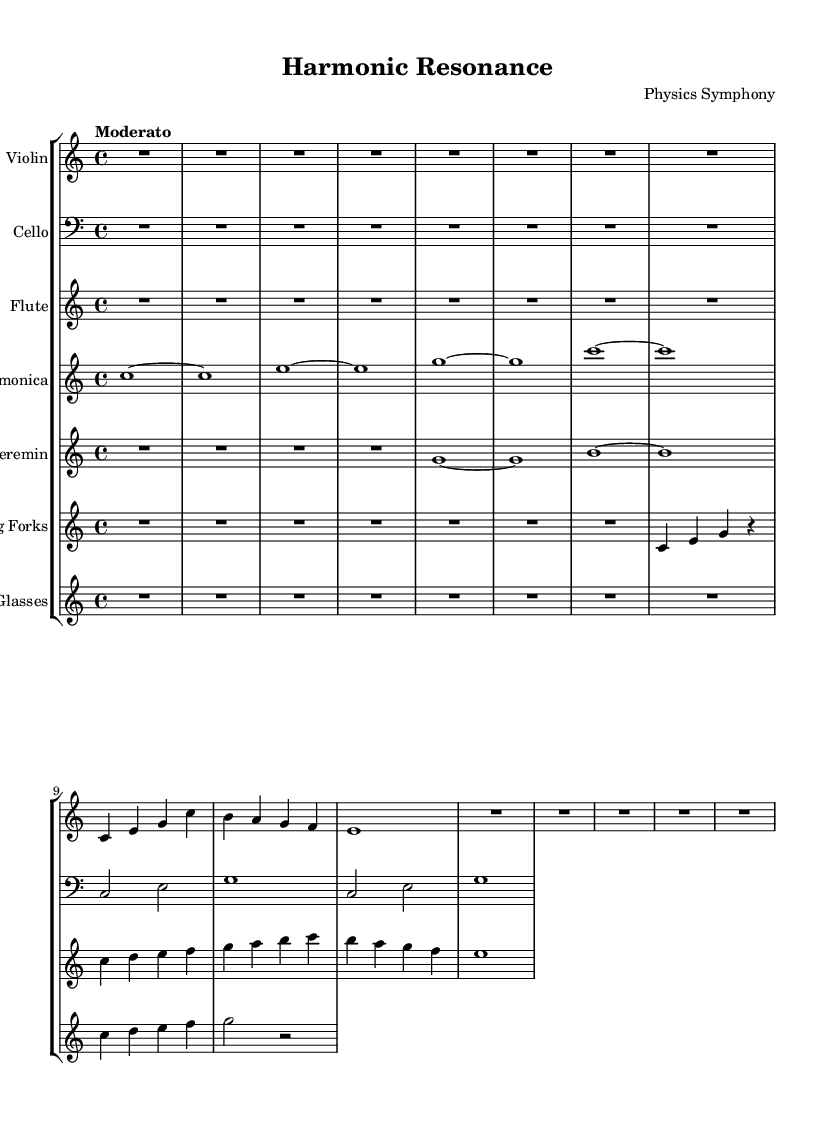What is the key signature of this music? The key signature is C major, which has no sharps or flats.
Answer: C major What is the time signature of this piece? The time signature is indicated at the beginning of the score, and it shows that each measure contains four beats.
Answer: 4/4 What is the tempo marking for this symphony? The tempo marking is written in the score as "Moderato," which indicates a moderate pace.
Answer: Moderato Which instruments are included in this symphonic piece? The symphonic piece features Violin, Cello, Flute, Glass Harmonica, Theremin, Tuning Forks, and Water Glasses, as indicated at the beginning of each staff in the score.
Answer: Violin, Cello, Flute, Glass Harmonica, Theremin, Tuning Forks, Water Glasses How many measures are present in the violin part? To determine the number of measures, we count the vertical lines separating the notes in the violin music. The piece has six measures.
Answer: 6 What unconventional instruments are used in this symphony? Unconventional instruments found in the score include the Glass Harmonica, Theremin, Tuning Forks, and Water Glasses, which are not typically found in standard orchestral compositions.
Answer: Glass Harmonica, Theremin, Tuning Forks, Water Glasses In which measure does the cello reach its highest pitch? By analyzing the cello music, we can identify that the highest pitch occurs in measure 4 with the note g.
Answer: Measure 4 